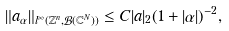Convert formula to latex. <formula><loc_0><loc_0><loc_500><loc_500>\| a _ { \alpha } \| _ { l ^ { \infty } ( { \mathbb { Z } } ^ { n } , { \mathcal { B } } ( { \mathbb { C } } ^ { N } ) ) } \leq C | a | _ { 2 } ( 1 + | \alpha | ) ^ { - 2 } ,</formula> 